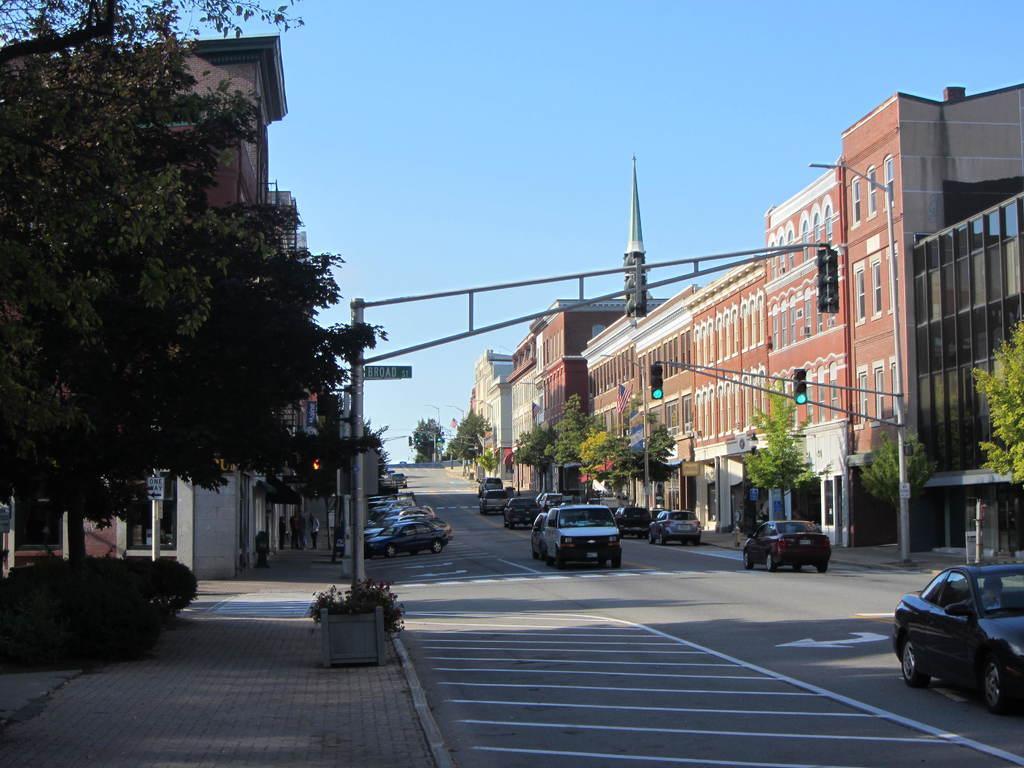Please provide a concise description of this image. At the top of the picture we can see a clear blue sky and it seems like a sunny day. On either side of the road we can see buildings, trees and cars. Here we can see a green board. This is a plant. This is a road. 